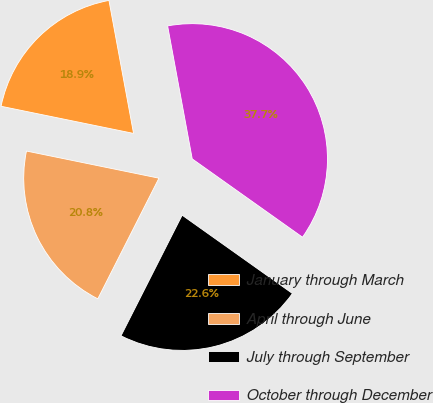<chart> <loc_0><loc_0><loc_500><loc_500><pie_chart><fcel>January through March<fcel>April through June<fcel>July through September<fcel>October through December<nl><fcel>18.87%<fcel>20.75%<fcel>22.64%<fcel>37.74%<nl></chart> 